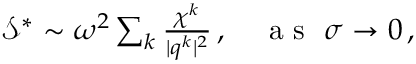Convert formula to latex. <formula><loc_0><loc_0><loc_500><loc_500>\begin{array} { r } { \mathcal { S } ^ { * } \sim \omega ^ { 2 } \sum _ { k } \frac { \chi ^ { k } } { | q ^ { k } | ^ { 2 } } \, , a s \sigma \rightarrow 0 \, , } \end{array}</formula> 